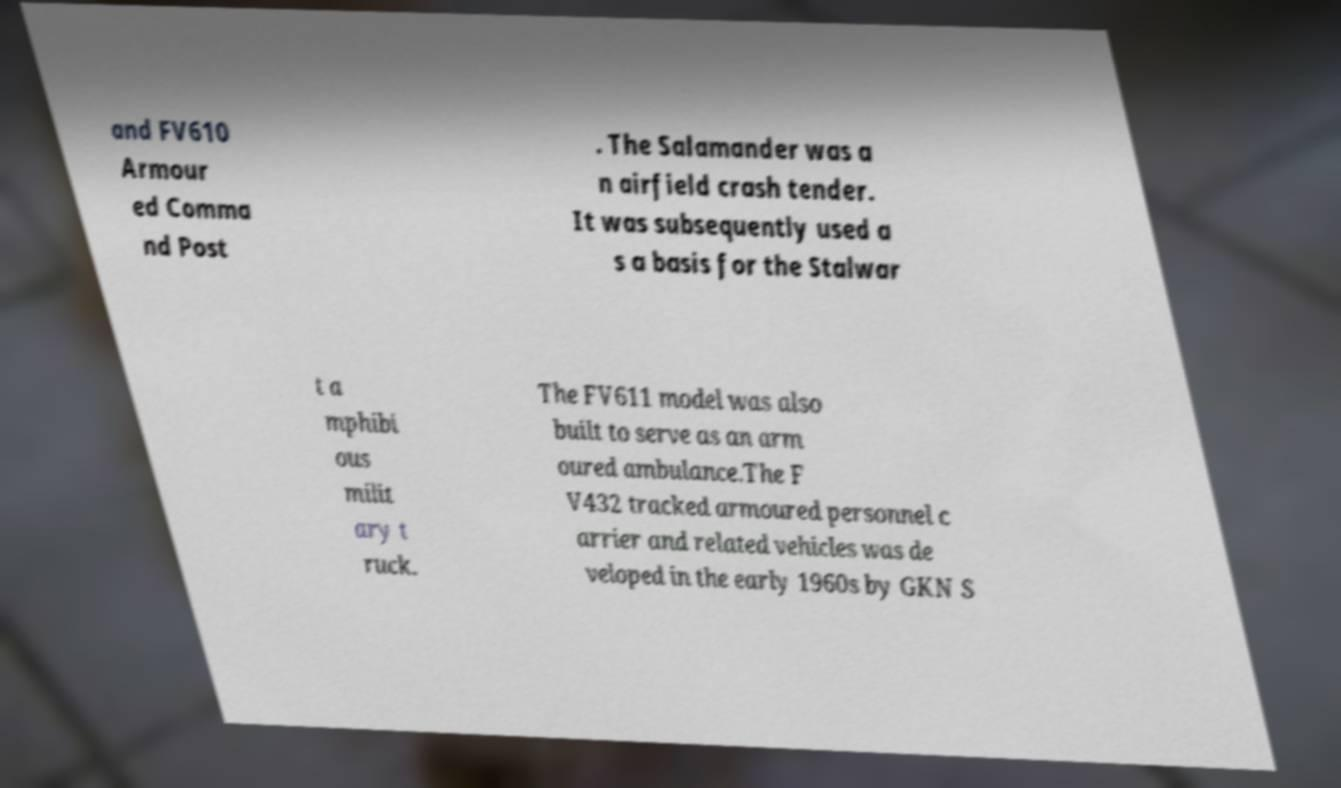I need the written content from this picture converted into text. Can you do that? and FV610 Armour ed Comma nd Post . The Salamander was a n airfield crash tender. It was subsequently used a s a basis for the Stalwar t a mphibi ous milit ary t ruck. The FV611 model was also built to serve as an arm oured ambulance.The F V432 tracked armoured personnel c arrier and related vehicles was de veloped in the early 1960s by GKN S 